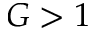Convert formula to latex. <formula><loc_0><loc_0><loc_500><loc_500>G > 1</formula> 